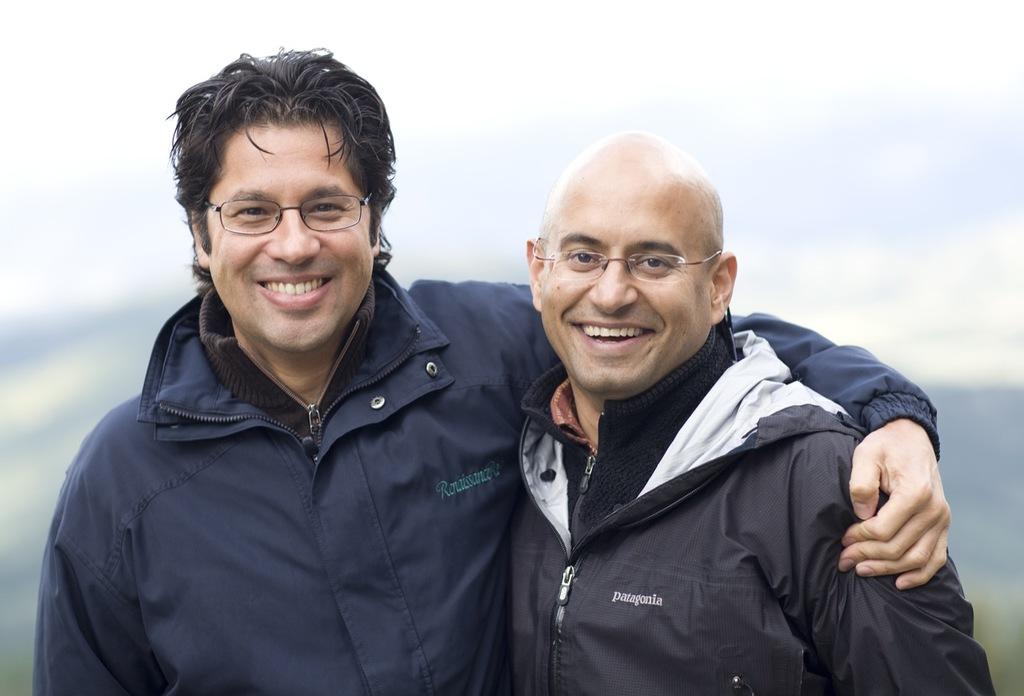What is the main subject in the image? There is a person standing in the image. Can you describe the background of the image? The background of the image is blurred. How many balls are floating in the air in the image? There are no balls or any indication of floating objects in the image. What type of creature is sitting on the desk in the image? There is no desk or any creature present in the image. 